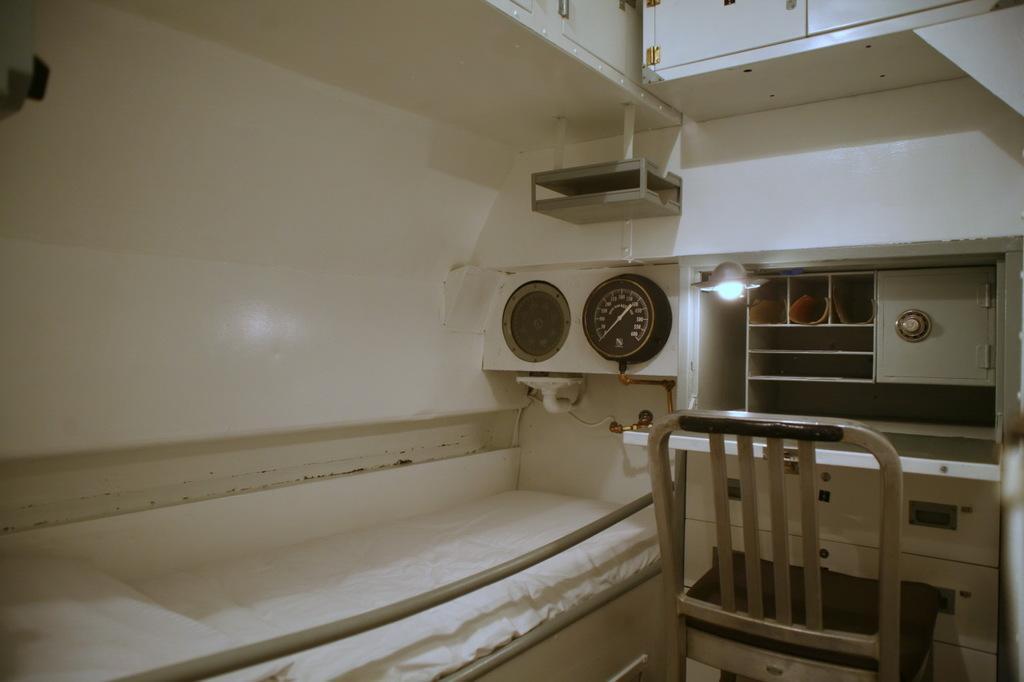Please provide a concise description of this image. In this image we can see an inner view of a room. In that we can see a bed with a pillow, chairs, a dial on the wall, a lamp and a wall. 